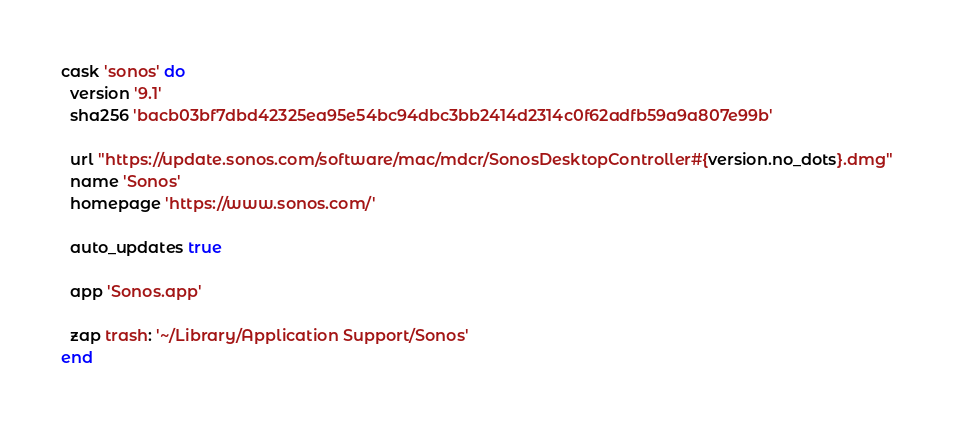<code> <loc_0><loc_0><loc_500><loc_500><_Ruby_>cask 'sonos' do
  version '9.1'
  sha256 'bacb03bf7dbd42325ea95e54bc94dbc3bb2414d2314c0f62adfb59a9a807e99b'

  url "https://update.sonos.com/software/mac/mdcr/SonosDesktopController#{version.no_dots}.dmg"
  name 'Sonos'
  homepage 'https://www.sonos.com/'

  auto_updates true

  app 'Sonos.app'

  zap trash: '~/Library/Application Support/Sonos'
end
</code> 